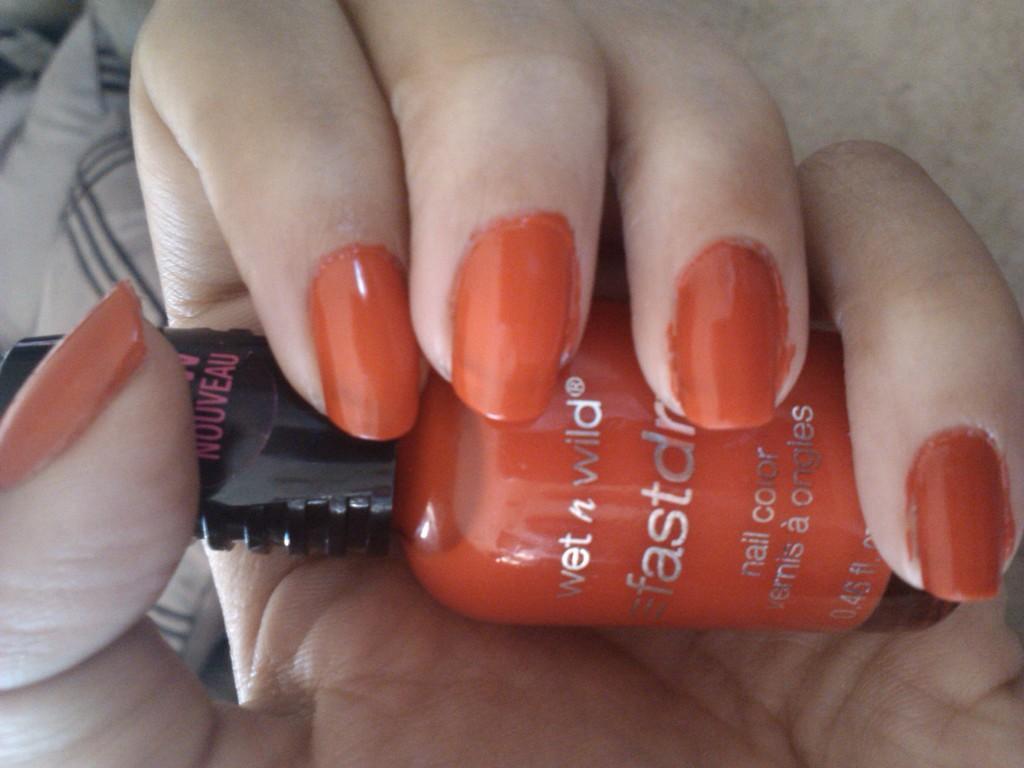Could you give a brief overview of what you see in this image? As we can see in the image, there is a human hand holding orange color nail polish in the hand. 